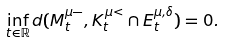<formula> <loc_0><loc_0><loc_500><loc_500>\inf _ { t \in \mathbb { R } } d ( M _ { t } ^ { \mu - } , K _ { t } ^ { \mu < } \cap E _ { t } ^ { \mu , \delta } ) = 0 .</formula> 